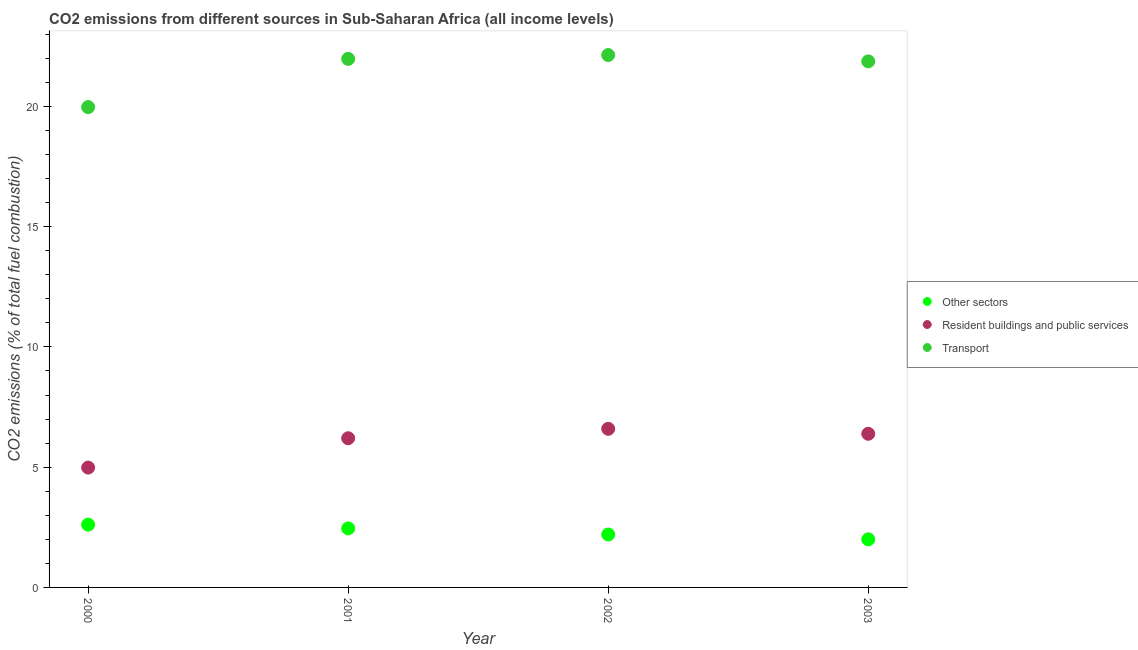How many different coloured dotlines are there?
Keep it short and to the point. 3. Is the number of dotlines equal to the number of legend labels?
Keep it short and to the point. Yes. What is the percentage of co2 emissions from transport in 2003?
Provide a short and direct response. 21.87. Across all years, what is the maximum percentage of co2 emissions from transport?
Offer a terse response. 22.14. Across all years, what is the minimum percentage of co2 emissions from transport?
Keep it short and to the point. 19.97. In which year was the percentage of co2 emissions from other sectors minimum?
Offer a terse response. 2003. What is the total percentage of co2 emissions from transport in the graph?
Provide a short and direct response. 85.96. What is the difference between the percentage of co2 emissions from resident buildings and public services in 2000 and that in 2003?
Offer a very short reply. -1.41. What is the difference between the percentage of co2 emissions from other sectors in 2003 and the percentage of co2 emissions from resident buildings and public services in 2001?
Ensure brevity in your answer.  -4.2. What is the average percentage of co2 emissions from other sectors per year?
Your answer should be compact. 2.32. In the year 2000, what is the difference between the percentage of co2 emissions from resident buildings and public services and percentage of co2 emissions from transport?
Provide a short and direct response. -14.99. In how many years, is the percentage of co2 emissions from other sectors greater than 21 %?
Give a very brief answer. 0. What is the ratio of the percentage of co2 emissions from resident buildings and public services in 2000 to that in 2001?
Your answer should be compact. 0.8. What is the difference between the highest and the second highest percentage of co2 emissions from resident buildings and public services?
Your answer should be very brief. 0.21. What is the difference between the highest and the lowest percentage of co2 emissions from resident buildings and public services?
Ensure brevity in your answer.  1.61. In how many years, is the percentage of co2 emissions from resident buildings and public services greater than the average percentage of co2 emissions from resident buildings and public services taken over all years?
Give a very brief answer. 3. Is the sum of the percentage of co2 emissions from resident buildings and public services in 2002 and 2003 greater than the maximum percentage of co2 emissions from other sectors across all years?
Keep it short and to the point. Yes. Is it the case that in every year, the sum of the percentage of co2 emissions from other sectors and percentage of co2 emissions from resident buildings and public services is greater than the percentage of co2 emissions from transport?
Give a very brief answer. No. Does the percentage of co2 emissions from transport monotonically increase over the years?
Make the answer very short. No. Is the percentage of co2 emissions from resident buildings and public services strictly greater than the percentage of co2 emissions from other sectors over the years?
Make the answer very short. Yes. Is the percentage of co2 emissions from transport strictly less than the percentage of co2 emissions from other sectors over the years?
Your answer should be compact. No. How many dotlines are there?
Your answer should be compact. 3. How many years are there in the graph?
Offer a very short reply. 4. Does the graph contain any zero values?
Make the answer very short. No. How many legend labels are there?
Your answer should be compact. 3. What is the title of the graph?
Provide a succinct answer. CO2 emissions from different sources in Sub-Saharan Africa (all income levels). What is the label or title of the Y-axis?
Your response must be concise. CO2 emissions (% of total fuel combustion). What is the CO2 emissions (% of total fuel combustion) of Other sectors in 2000?
Give a very brief answer. 2.61. What is the CO2 emissions (% of total fuel combustion) in Resident buildings and public services in 2000?
Your answer should be very brief. 4.98. What is the CO2 emissions (% of total fuel combustion) of Transport in 2000?
Provide a succinct answer. 19.97. What is the CO2 emissions (% of total fuel combustion) of Other sectors in 2001?
Make the answer very short. 2.45. What is the CO2 emissions (% of total fuel combustion) of Resident buildings and public services in 2001?
Provide a succinct answer. 6.2. What is the CO2 emissions (% of total fuel combustion) of Transport in 2001?
Offer a very short reply. 21.98. What is the CO2 emissions (% of total fuel combustion) in Other sectors in 2002?
Your answer should be compact. 2.2. What is the CO2 emissions (% of total fuel combustion) in Resident buildings and public services in 2002?
Keep it short and to the point. 6.6. What is the CO2 emissions (% of total fuel combustion) of Transport in 2002?
Give a very brief answer. 22.14. What is the CO2 emissions (% of total fuel combustion) of Other sectors in 2003?
Your response must be concise. 2. What is the CO2 emissions (% of total fuel combustion) of Resident buildings and public services in 2003?
Ensure brevity in your answer.  6.39. What is the CO2 emissions (% of total fuel combustion) in Transport in 2003?
Ensure brevity in your answer.  21.87. Across all years, what is the maximum CO2 emissions (% of total fuel combustion) in Other sectors?
Your answer should be very brief. 2.61. Across all years, what is the maximum CO2 emissions (% of total fuel combustion) of Resident buildings and public services?
Provide a succinct answer. 6.6. Across all years, what is the maximum CO2 emissions (% of total fuel combustion) in Transport?
Provide a short and direct response. 22.14. Across all years, what is the minimum CO2 emissions (% of total fuel combustion) in Other sectors?
Offer a very short reply. 2. Across all years, what is the minimum CO2 emissions (% of total fuel combustion) in Resident buildings and public services?
Keep it short and to the point. 4.98. Across all years, what is the minimum CO2 emissions (% of total fuel combustion) of Transport?
Your answer should be very brief. 19.97. What is the total CO2 emissions (% of total fuel combustion) in Other sectors in the graph?
Keep it short and to the point. 9.27. What is the total CO2 emissions (% of total fuel combustion) in Resident buildings and public services in the graph?
Your answer should be compact. 24.17. What is the total CO2 emissions (% of total fuel combustion) of Transport in the graph?
Ensure brevity in your answer.  85.96. What is the difference between the CO2 emissions (% of total fuel combustion) of Other sectors in 2000 and that in 2001?
Keep it short and to the point. 0.16. What is the difference between the CO2 emissions (% of total fuel combustion) of Resident buildings and public services in 2000 and that in 2001?
Ensure brevity in your answer.  -1.22. What is the difference between the CO2 emissions (% of total fuel combustion) in Transport in 2000 and that in 2001?
Your answer should be very brief. -2. What is the difference between the CO2 emissions (% of total fuel combustion) in Other sectors in 2000 and that in 2002?
Provide a succinct answer. 0.41. What is the difference between the CO2 emissions (% of total fuel combustion) of Resident buildings and public services in 2000 and that in 2002?
Offer a terse response. -1.61. What is the difference between the CO2 emissions (% of total fuel combustion) of Transport in 2000 and that in 2002?
Provide a succinct answer. -2.16. What is the difference between the CO2 emissions (% of total fuel combustion) of Other sectors in 2000 and that in 2003?
Provide a succinct answer. 0.61. What is the difference between the CO2 emissions (% of total fuel combustion) in Resident buildings and public services in 2000 and that in 2003?
Provide a short and direct response. -1.41. What is the difference between the CO2 emissions (% of total fuel combustion) in Transport in 2000 and that in 2003?
Your response must be concise. -1.9. What is the difference between the CO2 emissions (% of total fuel combustion) in Other sectors in 2001 and that in 2002?
Your answer should be compact. 0.25. What is the difference between the CO2 emissions (% of total fuel combustion) of Resident buildings and public services in 2001 and that in 2002?
Ensure brevity in your answer.  -0.39. What is the difference between the CO2 emissions (% of total fuel combustion) in Transport in 2001 and that in 2002?
Keep it short and to the point. -0.16. What is the difference between the CO2 emissions (% of total fuel combustion) of Other sectors in 2001 and that in 2003?
Your response must be concise. 0.46. What is the difference between the CO2 emissions (% of total fuel combustion) in Resident buildings and public services in 2001 and that in 2003?
Your answer should be compact. -0.18. What is the difference between the CO2 emissions (% of total fuel combustion) of Transport in 2001 and that in 2003?
Your response must be concise. 0.1. What is the difference between the CO2 emissions (% of total fuel combustion) of Other sectors in 2002 and that in 2003?
Provide a short and direct response. 0.2. What is the difference between the CO2 emissions (% of total fuel combustion) of Resident buildings and public services in 2002 and that in 2003?
Offer a very short reply. 0.21. What is the difference between the CO2 emissions (% of total fuel combustion) of Transport in 2002 and that in 2003?
Your answer should be very brief. 0.26. What is the difference between the CO2 emissions (% of total fuel combustion) in Other sectors in 2000 and the CO2 emissions (% of total fuel combustion) in Resident buildings and public services in 2001?
Keep it short and to the point. -3.59. What is the difference between the CO2 emissions (% of total fuel combustion) in Other sectors in 2000 and the CO2 emissions (% of total fuel combustion) in Transport in 2001?
Offer a terse response. -19.37. What is the difference between the CO2 emissions (% of total fuel combustion) of Resident buildings and public services in 2000 and the CO2 emissions (% of total fuel combustion) of Transport in 2001?
Give a very brief answer. -16.99. What is the difference between the CO2 emissions (% of total fuel combustion) in Other sectors in 2000 and the CO2 emissions (% of total fuel combustion) in Resident buildings and public services in 2002?
Your response must be concise. -3.98. What is the difference between the CO2 emissions (% of total fuel combustion) in Other sectors in 2000 and the CO2 emissions (% of total fuel combustion) in Transport in 2002?
Your answer should be very brief. -19.53. What is the difference between the CO2 emissions (% of total fuel combustion) of Resident buildings and public services in 2000 and the CO2 emissions (% of total fuel combustion) of Transport in 2002?
Keep it short and to the point. -17.15. What is the difference between the CO2 emissions (% of total fuel combustion) in Other sectors in 2000 and the CO2 emissions (% of total fuel combustion) in Resident buildings and public services in 2003?
Ensure brevity in your answer.  -3.78. What is the difference between the CO2 emissions (% of total fuel combustion) in Other sectors in 2000 and the CO2 emissions (% of total fuel combustion) in Transport in 2003?
Provide a short and direct response. -19.26. What is the difference between the CO2 emissions (% of total fuel combustion) of Resident buildings and public services in 2000 and the CO2 emissions (% of total fuel combustion) of Transport in 2003?
Your response must be concise. -16.89. What is the difference between the CO2 emissions (% of total fuel combustion) in Other sectors in 2001 and the CO2 emissions (% of total fuel combustion) in Resident buildings and public services in 2002?
Your answer should be very brief. -4.14. What is the difference between the CO2 emissions (% of total fuel combustion) of Other sectors in 2001 and the CO2 emissions (% of total fuel combustion) of Transport in 2002?
Provide a succinct answer. -19.68. What is the difference between the CO2 emissions (% of total fuel combustion) of Resident buildings and public services in 2001 and the CO2 emissions (% of total fuel combustion) of Transport in 2002?
Give a very brief answer. -15.93. What is the difference between the CO2 emissions (% of total fuel combustion) of Other sectors in 2001 and the CO2 emissions (% of total fuel combustion) of Resident buildings and public services in 2003?
Your response must be concise. -3.93. What is the difference between the CO2 emissions (% of total fuel combustion) in Other sectors in 2001 and the CO2 emissions (% of total fuel combustion) in Transport in 2003?
Offer a terse response. -19.42. What is the difference between the CO2 emissions (% of total fuel combustion) of Resident buildings and public services in 2001 and the CO2 emissions (% of total fuel combustion) of Transport in 2003?
Your answer should be very brief. -15.67. What is the difference between the CO2 emissions (% of total fuel combustion) in Other sectors in 2002 and the CO2 emissions (% of total fuel combustion) in Resident buildings and public services in 2003?
Keep it short and to the point. -4.19. What is the difference between the CO2 emissions (% of total fuel combustion) in Other sectors in 2002 and the CO2 emissions (% of total fuel combustion) in Transport in 2003?
Make the answer very short. -19.67. What is the difference between the CO2 emissions (% of total fuel combustion) of Resident buildings and public services in 2002 and the CO2 emissions (% of total fuel combustion) of Transport in 2003?
Your answer should be compact. -15.28. What is the average CO2 emissions (% of total fuel combustion) of Other sectors per year?
Your response must be concise. 2.32. What is the average CO2 emissions (% of total fuel combustion) of Resident buildings and public services per year?
Keep it short and to the point. 6.04. What is the average CO2 emissions (% of total fuel combustion) of Transport per year?
Give a very brief answer. 21.49. In the year 2000, what is the difference between the CO2 emissions (% of total fuel combustion) in Other sectors and CO2 emissions (% of total fuel combustion) in Resident buildings and public services?
Provide a short and direct response. -2.37. In the year 2000, what is the difference between the CO2 emissions (% of total fuel combustion) in Other sectors and CO2 emissions (% of total fuel combustion) in Transport?
Ensure brevity in your answer.  -17.36. In the year 2000, what is the difference between the CO2 emissions (% of total fuel combustion) in Resident buildings and public services and CO2 emissions (% of total fuel combustion) in Transport?
Your answer should be very brief. -14.99. In the year 2001, what is the difference between the CO2 emissions (% of total fuel combustion) of Other sectors and CO2 emissions (% of total fuel combustion) of Resident buildings and public services?
Provide a short and direct response. -3.75. In the year 2001, what is the difference between the CO2 emissions (% of total fuel combustion) of Other sectors and CO2 emissions (% of total fuel combustion) of Transport?
Your answer should be compact. -19.52. In the year 2001, what is the difference between the CO2 emissions (% of total fuel combustion) of Resident buildings and public services and CO2 emissions (% of total fuel combustion) of Transport?
Make the answer very short. -15.77. In the year 2002, what is the difference between the CO2 emissions (% of total fuel combustion) in Other sectors and CO2 emissions (% of total fuel combustion) in Resident buildings and public services?
Keep it short and to the point. -4.39. In the year 2002, what is the difference between the CO2 emissions (% of total fuel combustion) of Other sectors and CO2 emissions (% of total fuel combustion) of Transport?
Provide a succinct answer. -19.94. In the year 2002, what is the difference between the CO2 emissions (% of total fuel combustion) of Resident buildings and public services and CO2 emissions (% of total fuel combustion) of Transport?
Your response must be concise. -15.54. In the year 2003, what is the difference between the CO2 emissions (% of total fuel combustion) in Other sectors and CO2 emissions (% of total fuel combustion) in Resident buildings and public services?
Ensure brevity in your answer.  -4.39. In the year 2003, what is the difference between the CO2 emissions (% of total fuel combustion) of Other sectors and CO2 emissions (% of total fuel combustion) of Transport?
Provide a short and direct response. -19.87. In the year 2003, what is the difference between the CO2 emissions (% of total fuel combustion) of Resident buildings and public services and CO2 emissions (% of total fuel combustion) of Transport?
Offer a very short reply. -15.49. What is the ratio of the CO2 emissions (% of total fuel combustion) of Other sectors in 2000 to that in 2001?
Your answer should be compact. 1.06. What is the ratio of the CO2 emissions (% of total fuel combustion) in Resident buildings and public services in 2000 to that in 2001?
Provide a short and direct response. 0.8. What is the ratio of the CO2 emissions (% of total fuel combustion) of Transport in 2000 to that in 2001?
Keep it short and to the point. 0.91. What is the ratio of the CO2 emissions (% of total fuel combustion) of Other sectors in 2000 to that in 2002?
Provide a succinct answer. 1.19. What is the ratio of the CO2 emissions (% of total fuel combustion) in Resident buildings and public services in 2000 to that in 2002?
Your answer should be compact. 0.76. What is the ratio of the CO2 emissions (% of total fuel combustion) of Transport in 2000 to that in 2002?
Provide a succinct answer. 0.9. What is the ratio of the CO2 emissions (% of total fuel combustion) of Other sectors in 2000 to that in 2003?
Offer a very short reply. 1.31. What is the ratio of the CO2 emissions (% of total fuel combustion) in Resident buildings and public services in 2000 to that in 2003?
Make the answer very short. 0.78. What is the ratio of the CO2 emissions (% of total fuel combustion) of Transport in 2000 to that in 2003?
Provide a short and direct response. 0.91. What is the ratio of the CO2 emissions (% of total fuel combustion) in Other sectors in 2001 to that in 2002?
Offer a terse response. 1.12. What is the ratio of the CO2 emissions (% of total fuel combustion) in Resident buildings and public services in 2001 to that in 2002?
Make the answer very short. 0.94. What is the ratio of the CO2 emissions (% of total fuel combustion) of Other sectors in 2001 to that in 2003?
Provide a succinct answer. 1.23. What is the ratio of the CO2 emissions (% of total fuel combustion) of Resident buildings and public services in 2001 to that in 2003?
Offer a terse response. 0.97. What is the ratio of the CO2 emissions (% of total fuel combustion) of Other sectors in 2002 to that in 2003?
Your answer should be compact. 1.1. What is the ratio of the CO2 emissions (% of total fuel combustion) in Resident buildings and public services in 2002 to that in 2003?
Give a very brief answer. 1.03. What is the ratio of the CO2 emissions (% of total fuel combustion) in Transport in 2002 to that in 2003?
Offer a terse response. 1.01. What is the difference between the highest and the second highest CO2 emissions (% of total fuel combustion) in Other sectors?
Provide a short and direct response. 0.16. What is the difference between the highest and the second highest CO2 emissions (% of total fuel combustion) in Resident buildings and public services?
Make the answer very short. 0.21. What is the difference between the highest and the second highest CO2 emissions (% of total fuel combustion) in Transport?
Offer a terse response. 0.16. What is the difference between the highest and the lowest CO2 emissions (% of total fuel combustion) in Other sectors?
Provide a succinct answer. 0.61. What is the difference between the highest and the lowest CO2 emissions (% of total fuel combustion) of Resident buildings and public services?
Offer a terse response. 1.61. What is the difference between the highest and the lowest CO2 emissions (% of total fuel combustion) of Transport?
Offer a very short reply. 2.16. 